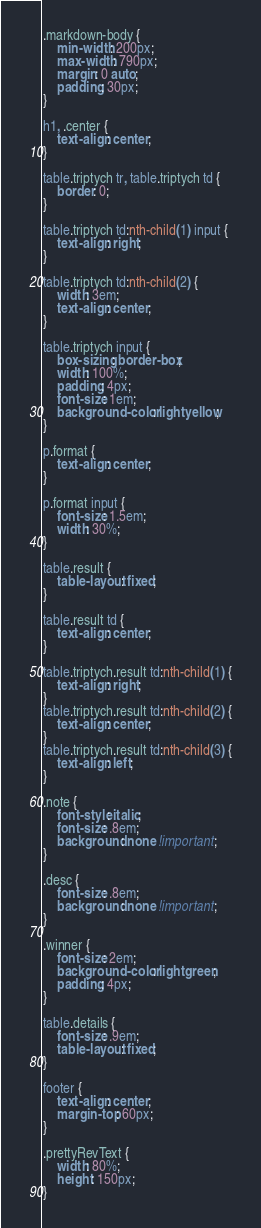Convert code to text. <code><loc_0><loc_0><loc_500><loc_500><_CSS_>.markdown-body {
    min-width: 200px;
    max-width: 790px;
    margin: 0 auto;
    padding: 30px;
}

h1, .center {
    text-align: center;
}

table.triptych tr, table.triptych td {
    border: 0;
}

table.triptych td:nth-child(1) input {
    text-align: right;
}

table.triptych td:nth-child(2) {
    width: 3em;
    text-align: center;
}

table.triptych input {
    box-sizing: border-box;
    width: 100%;
    padding: 4px;
    font-size: 1em;
    background-color: lightyellow;
}

p.format {
    text-align: center;
}

p.format input {
    font-size: 1.5em;
    width: 30%;
}

table.result {
    table-layout: fixed;
}

table.result td {
    text-align: center;
}

table.triptych.result td:nth-child(1) {
    text-align: right;
}
table.triptych.result td:nth-child(2) {
    text-align: center;
}
table.triptych.result td:nth-child(3) {
    text-align: left;
}

.note {
    font-style: italic;
    font-size: .8em;
    background: none !important;
}

.desc {
    font-size: .8em;
    background: none !important;
}

.winner {
    font-size: 2em;
    background-color: lightgreen;
    padding: 4px;
}

table.details {
    font-size: .9em;
    table-layout: fixed;
}

footer {
    text-align: center;
    margin-top: 60px;
}

.prettyRevText {
    width: 80%;
    height: 150px;
}
</code> 